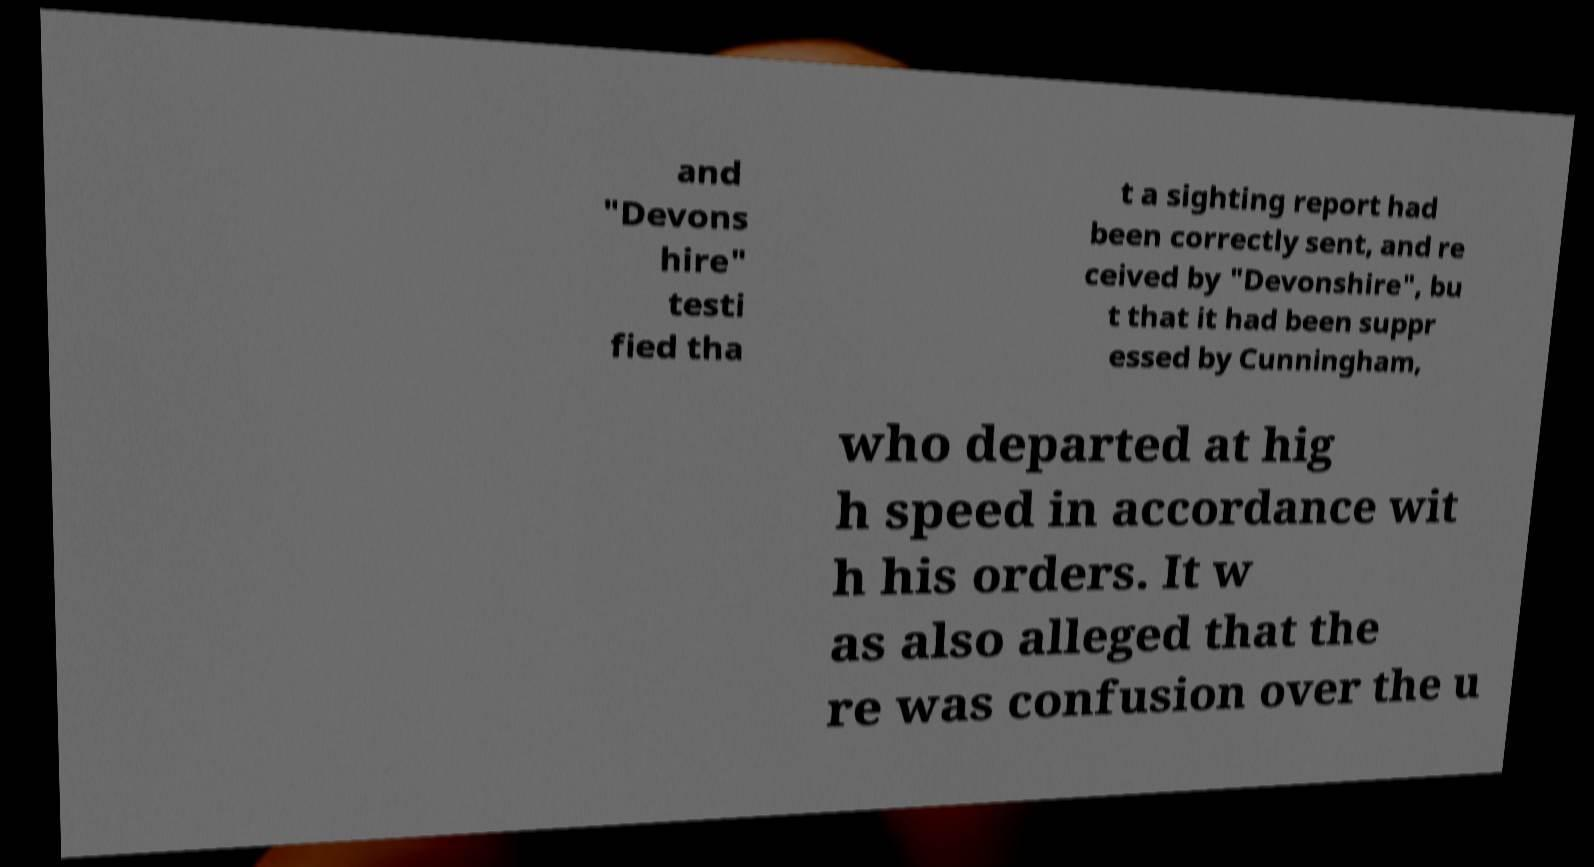I need the written content from this picture converted into text. Can you do that? and "Devons hire" testi fied tha t a sighting report had been correctly sent, and re ceived by "Devonshire", bu t that it had been suppr essed by Cunningham, who departed at hig h speed in accordance wit h his orders. It w as also alleged that the re was confusion over the u 